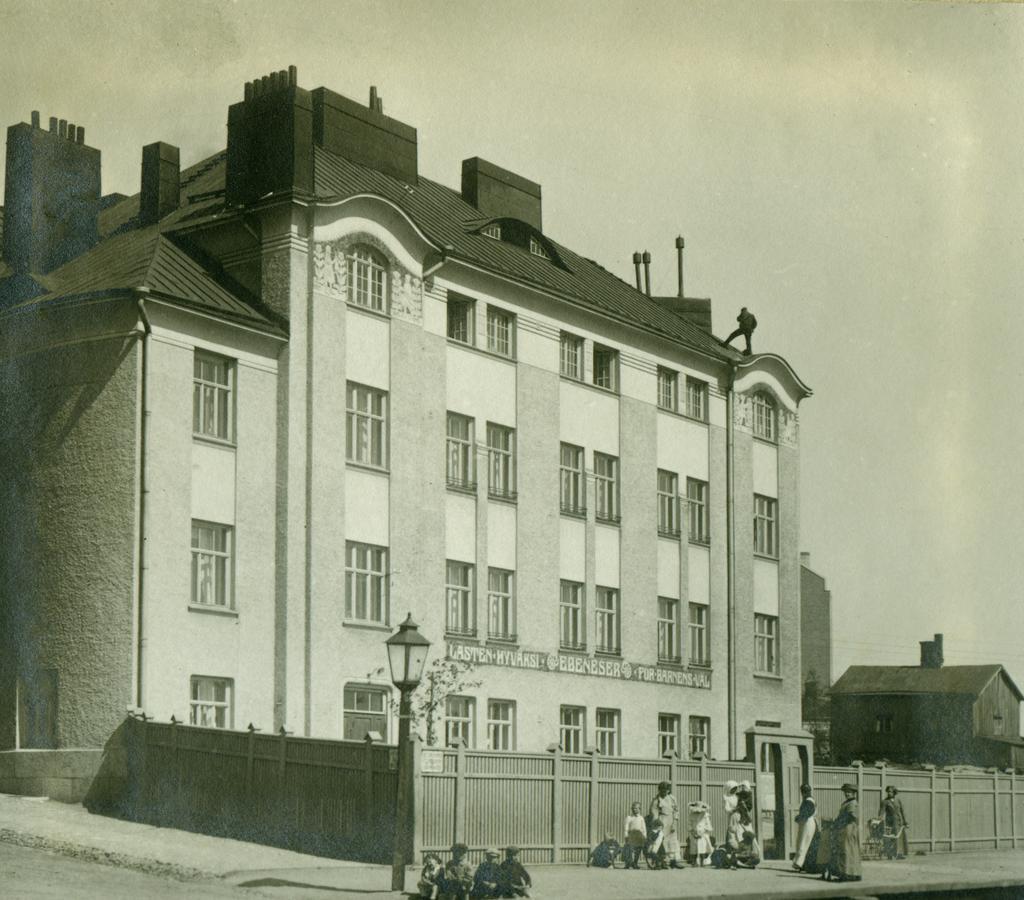Could you give a brief overview of what you see in this image? This is a black and white image. There is building in the middle. There is light in the middle. There are some persons at the bottom. There is sky at the top. 